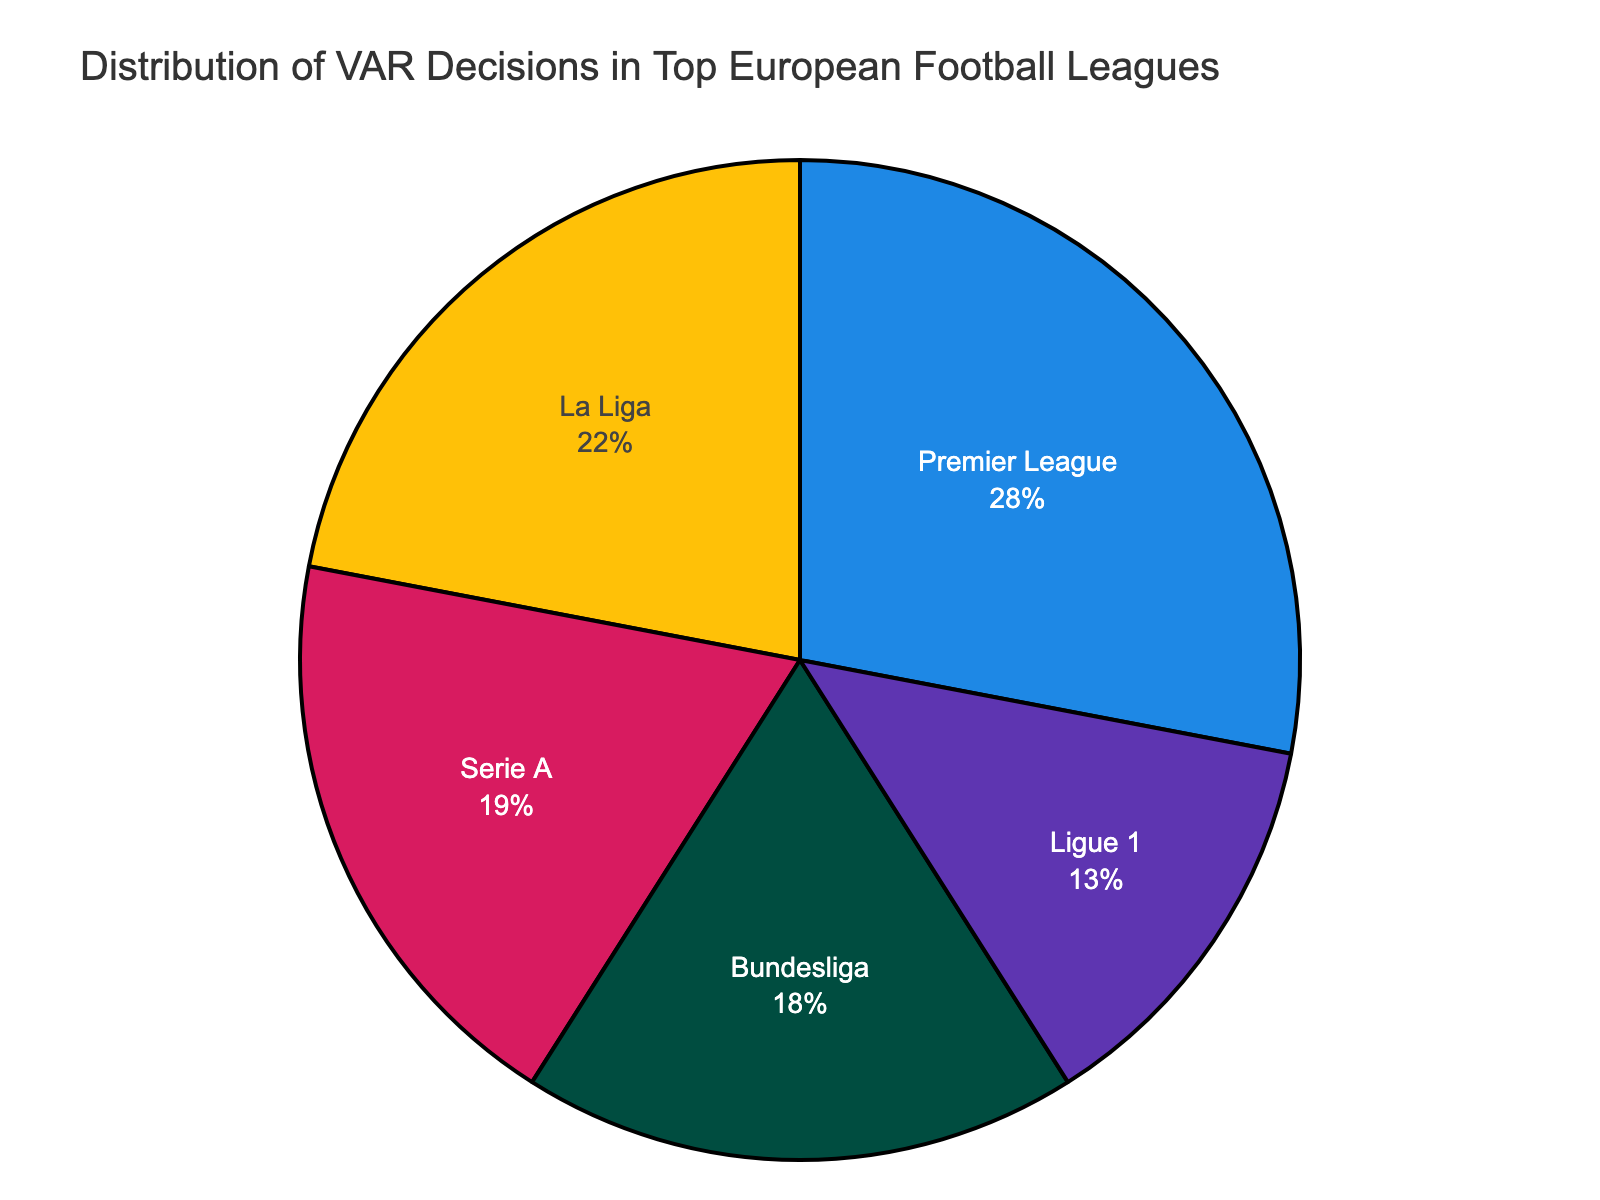How many leagues have a higher percentage of VAR decisions than La Liga? La Liga has 22%. The Premier League has 28%, Serie A has 19%, the Bundesliga has 18%, and Ligue 1 has 13%. Both Serie A and Premier League have higher percentages than La Liga.
Answer: Two Which league has the lowest percentage of VAR decisions? The pie chart shows that Ligue 1 has the smallest segment, indicating it has the lowest percentage.
Answer: Ligue 1 What is the difference in the percentage of VAR decisions between Premier League and Bundesliga? Premier League has 28% and Bundesliga has 18%. The difference is 28% - 18% = 10%.
Answer: 10% What is the total percentage of VAR decisions accounted for by Serie A and La Liga combined? Serie A has 19% and La Liga has 22%. Combined, they account for 19% + 22% = 41%.
Answer: 41% Which league's percentage of VAR decisions is closest to one-fifth of the total? One-fifth of 100% is 20%. Serie A has 19%, which is closest to 20%.
Answer: Serie A How does the percentage of VAR decisions in Ligue 1 compare to that in Serie A? Serie A has 19% and Ligue 1 has 13%. Ligue 1's percentage is less than Serie A's by 19% - 13% = 6%.
Answer: Ligue 1 is less by 6% If Premier League had 5% more VAR decisions, what would its new percentage be? Premier League currently has 28%. Adding 5%, it becomes 28% + 5% = 33%.
Answer: 33% Which two leagues combined exceed 50% in their VAR decisions? The Premier League with 28% combined with La Liga's 22% gives a sum of 50%. However, to exceed, we check Premier League (28%) and Bundesliga (18%), which total 46%. Adding Serie A’s 19% would exceed 50%. Therefore, Premier League and La Liga combined do not exceed, but Premier League and Serie A will exceed: 28% + 19% = 47%. Only Premier League and another smaller league can’t exceed 50%. Thus, no exact combination of two leagues exceeds 50%.
Answer: None 